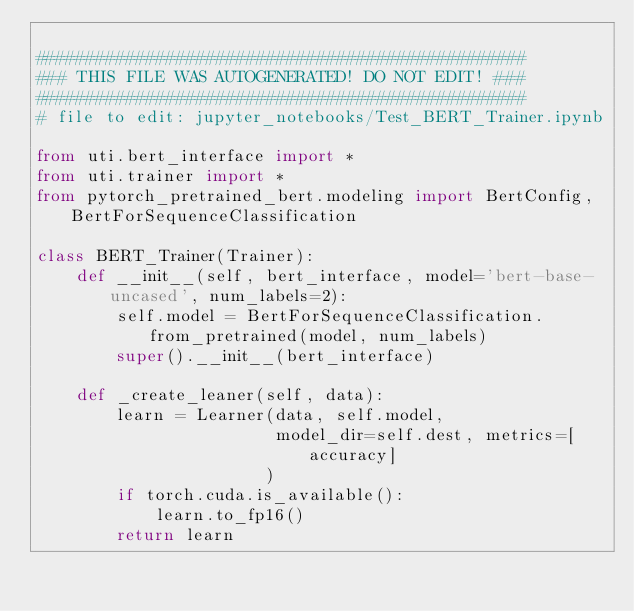Convert code to text. <code><loc_0><loc_0><loc_500><loc_500><_Python_>
#################################################
### THIS FILE WAS AUTOGENERATED! DO NOT EDIT! ###
#################################################
# file to edit: jupyter_notebooks/Test_BERT_Trainer.ipynb

from uti.bert_interface import *
from uti.trainer import *
from pytorch_pretrained_bert.modeling import BertConfig, BertForSequenceClassification

class BERT_Trainer(Trainer):
    def __init__(self, bert_interface, model='bert-base-uncased', num_labels=2):
        self.model = BertForSequenceClassification.from_pretrained(model, num_labels)
        super().__init__(bert_interface)

    def _create_leaner(self, data):
        learn = Learner(data, self.model,
                        model_dir=self.dest, metrics=[accuracy]
                       )
        if torch.cuda.is_available():
            learn.to_fp16()
        return learn</code> 